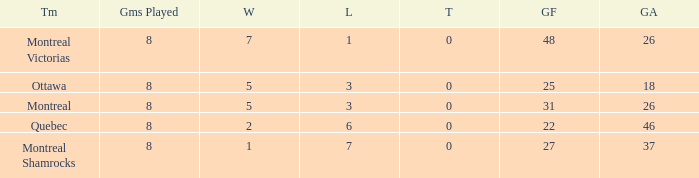For teams with fewer than 5 wins, goals against over 37, and fewer than 8 games played, what is the average number of ties? None. 